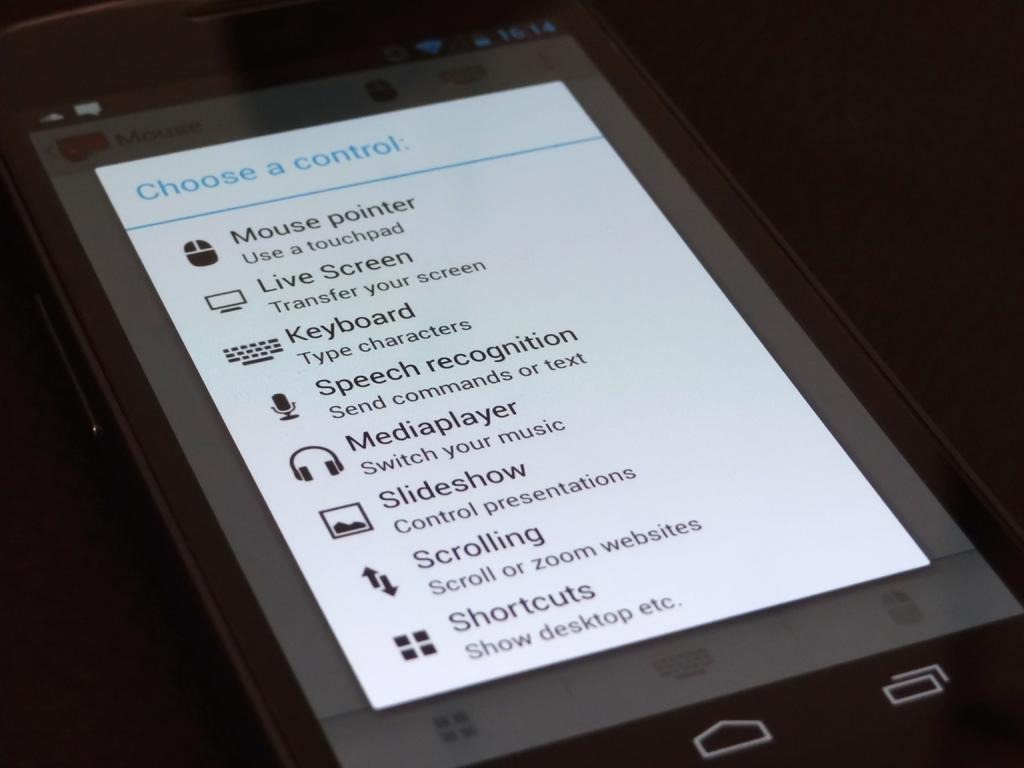<image>
Offer a succinct explanation of the picture presented. A cellphone screen display showing the Choose a Control tab 